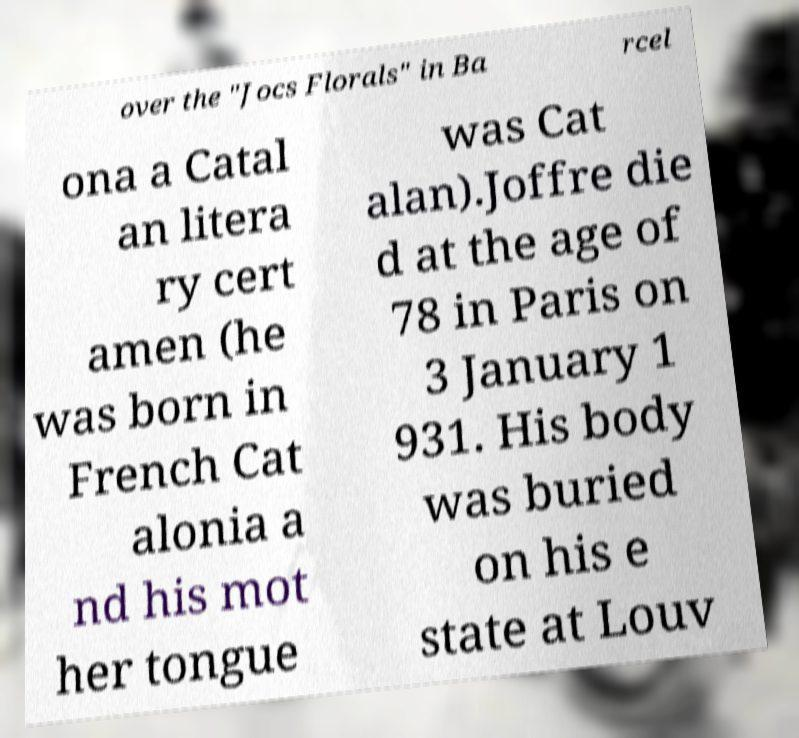There's text embedded in this image that I need extracted. Can you transcribe it verbatim? over the "Jocs Florals" in Ba rcel ona a Catal an litera ry cert amen (he was born in French Cat alonia a nd his mot her tongue was Cat alan).Joffre die d at the age of 78 in Paris on 3 January 1 931. His body was buried on his e state at Louv 